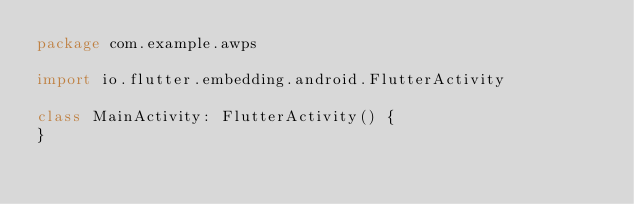Convert code to text. <code><loc_0><loc_0><loc_500><loc_500><_Kotlin_>package com.example.awps

import io.flutter.embedding.android.FlutterActivity

class MainActivity: FlutterActivity() {
}
</code> 